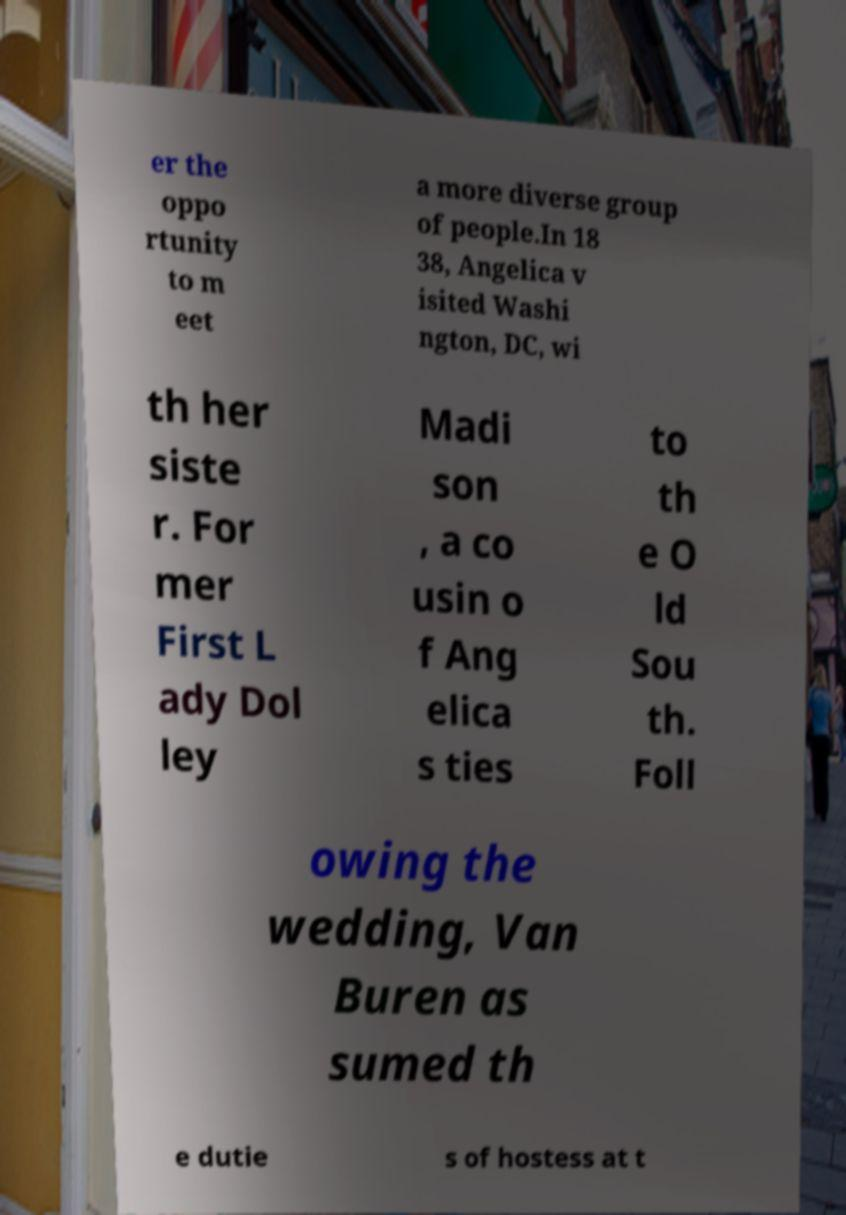There's text embedded in this image that I need extracted. Can you transcribe it verbatim? er the oppo rtunity to m eet a more diverse group of people.In 18 38, Angelica v isited Washi ngton, DC, wi th her siste r. For mer First L ady Dol ley Madi son , a co usin o f Ang elica s ties to th e O ld Sou th. Foll owing the wedding, Van Buren as sumed th e dutie s of hostess at t 